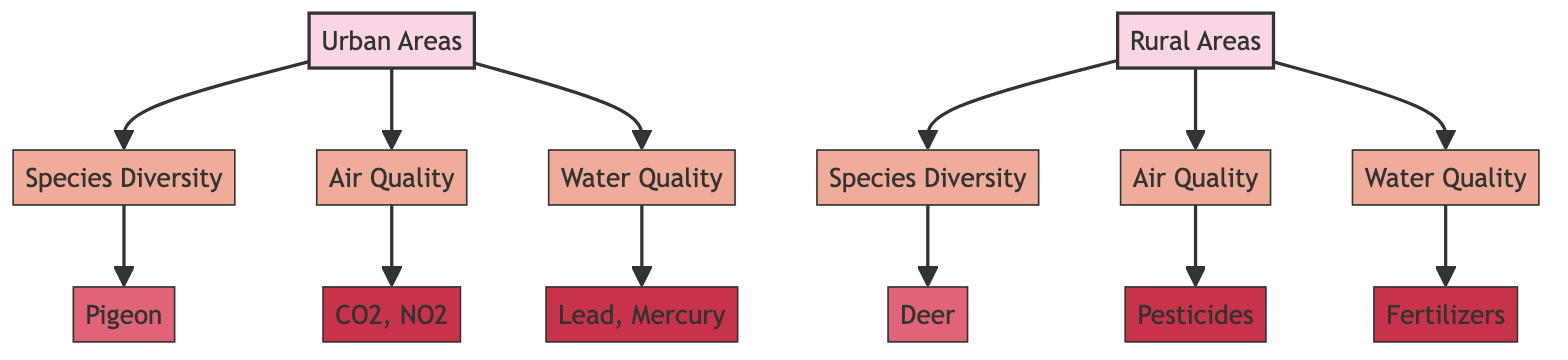What is the species diversity metric for urban areas? The diagram indicates that the species diversity metric for urban areas is represented by the node linked to Urban Areas labeled as Species Diversity (SDU). The direct connection indicates that this metric pertains specifically to urban environments.
Answer: Species Diversity What type of species is represented under rural areas? The diagram shows that the node linked to Rural Areas specifies the species represented as Deer (SER). This indicates the focus on species diversity in rural conditions, specifically noting Deer as the example species.
Answer: Deer How many attributes affect air quality in urban areas? In the diagram, the Urban Areas node connects to the Air Quality node (AQU), which is further connected to the attribute node (PU) indicating that CO2 and NO2 are the key elements affecting urban air quality. Thus, there is one attribute category represented here.
Answer: One What is the water quality attribute affecting rural areas? The node Water Quality (WQR) is linked to Rural Areas (RA) in the diagram and is connected to the Fertilizers attribute (CR). This relationship indicates that Fertilizers are the attribute affecting water quality specifically in rural areas.
Answer: Fertilizers Compare the air quality attributed for urban and rural areas. The diagram shows that urban areas have air quality influenced by CO2 and NO2 (PU), while rural areas are impacted by Pesticides (PR, linked to AQR). The comparison highlights that urban air quality is affected by more typical urban pollutants, while rural areas face challenges from agricultural chemicals.
Answer: CO2, NO2 vs. Pesticides Which species diversity is greater, urban or rural? The diagram connects Urban Areas to Species Diversity (SDU) and Rural Areas to Species Diversity (SDR). By noting the connections, the species diversity metrics can be compared directly. However, the specific values are not indicated in the diagram, necessitating external data for a complete answer.
Answer: Not specified What are the two components affecting urban water quality? The diagram illustrates that the Urban Areas (UA) node connects to the Water Quality (WQU) node, which in turn is linked to the attributes of Lead and Mercury (CU). This indicates these two specific components are relevant to urban water quality metrics.
Answer: Lead, Mercury How do air quality metrics differ between urban and rural areas? The Urban Areas (UA) air quality is impacted by pollutants CO2 and NO2 whereas the Rural Areas (RA) are influenced by Pesticides. Therefore, the difference lies in the types of pollutants affecting air quality, with urban areas being affected primarily by vehicular and industrial emissions, and rural areas by agricultural chemicals.
Answer: CO2, NO2 vs. Pesticides 